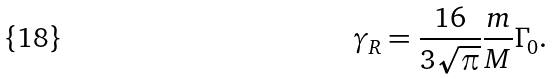<formula> <loc_0><loc_0><loc_500><loc_500>\gamma _ { R } = \frac { 1 6 } { 3 \sqrt { \pi } } \frac { m } { M } \Gamma _ { 0 } .</formula> 